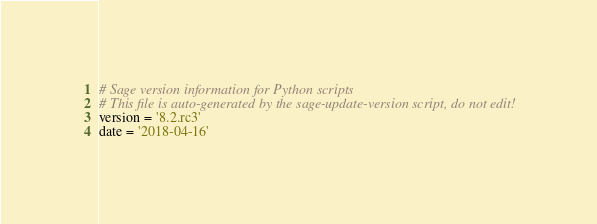Convert code to text. <code><loc_0><loc_0><loc_500><loc_500><_Python_># Sage version information for Python scripts
# This file is auto-generated by the sage-update-version script, do not edit!
version = '8.2.rc3'
date = '2018-04-16'
</code> 